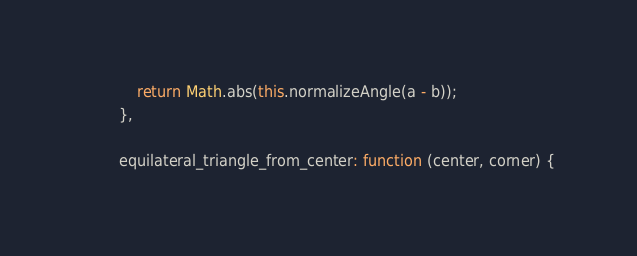<code> <loc_0><loc_0><loc_500><loc_500><_JavaScript_>            return Math.abs(this.normalizeAngle(a - b));
        },

        equilateral_triangle_from_center: function (center, corner) {</code> 